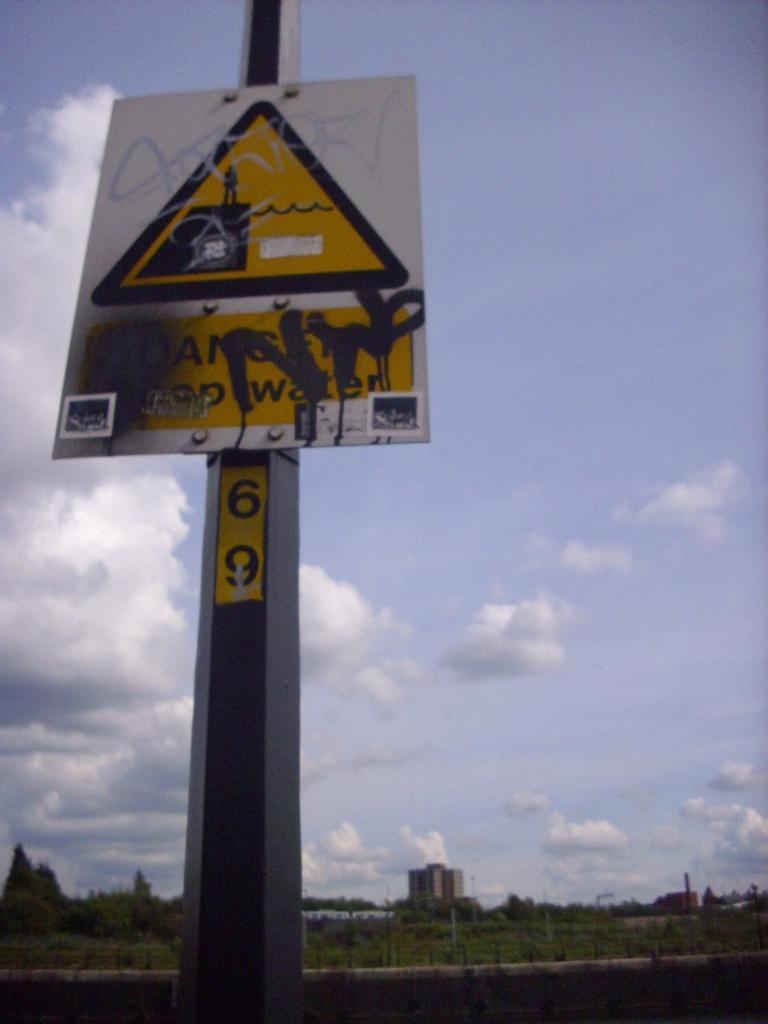What is located in the foreground of the image? There is a sign board in the foreground of the image. How is the sign board supported in the image? The sign board is attached to a pole. What can be seen in the background of the image? There are trees, buildings, and the sky visible in the background of the image. What is the condition of the sky in the image? The sky is visible in the background of the image, and there are clouds present. What type of animal can be seen reacting to the sign board in the image? There are no animals present in the image, and therefore no reactions to the sign board can be observed. 